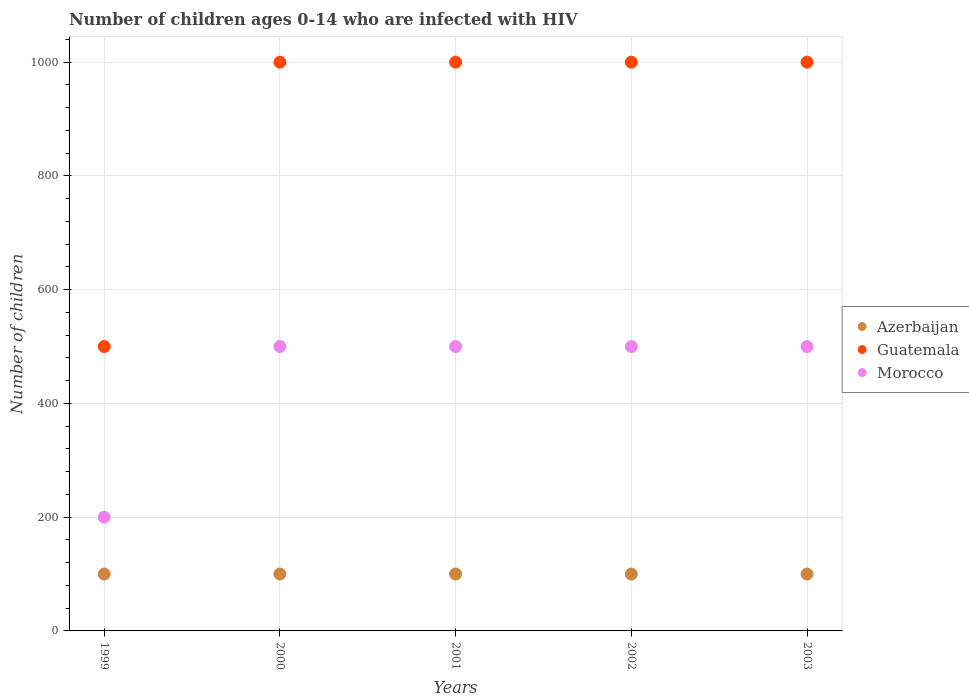What is the number of HIV infected children in Morocco in 1999?
Keep it short and to the point. 200. Across all years, what is the maximum number of HIV infected children in Azerbaijan?
Give a very brief answer. 100. Across all years, what is the minimum number of HIV infected children in Morocco?
Your answer should be very brief. 200. What is the total number of HIV infected children in Guatemala in the graph?
Your answer should be very brief. 4500. What is the difference between the number of HIV infected children in Morocco in 1999 and that in 2003?
Ensure brevity in your answer.  -300. What is the difference between the number of HIV infected children in Azerbaijan in 2003 and the number of HIV infected children in Guatemala in 1999?
Give a very brief answer. -400. In the year 2000, what is the difference between the number of HIV infected children in Azerbaijan and number of HIV infected children in Guatemala?
Your answer should be compact. -900. What is the ratio of the number of HIV infected children in Azerbaijan in 1999 to that in 2001?
Offer a terse response. 1. Is the number of HIV infected children in Morocco in 2001 less than that in 2003?
Give a very brief answer. No. Is the sum of the number of HIV infected children in Guatemala in 2000 and 2001 greater than the maximum number of HIV infected children in Azerbaijan across all years?
Offer a terse response. Yes. Is it the case that in every year, the sum of the number of HIV infected children in Guatemala and number of HIV infected children in Azerbaijan  is greater than the number of HIV infected children in Morocco?
Ensure brevity in your answer.  Yes. Is the number of HIV infected children in Morocco strictly greater than the number of HIV infected children in Guatemala over the years?
Give a very brief answer. No. Is the number of HIV infected children in Azerbaijan strictly less than the number of HIV infected children in Guatemala over the years?
Keep it short and to the point. Yes. How many years are there in the graph?
Offer a very short reply. 5. Does the graph contain any zero values?
Your answer should be compact. No. Does the graph contain grids?
Your response must be concise. Yes. How many legend labels are there?
Provide a short and direct response. 3. What is the title of the graph?
Ensure brevity in your answer.  Number of children ages 0-14 who are infected with HIV. Does "Dominican Republic" appear as one of the legend labels in the graph?
Offer a very short reply. No. What is the label or title of the Y-axis?
Offer a terse response. Number of children. What is the Number of children of Morocco in 1999?
Offer a very short reply. 200. What is the Number of children of Morocco in 2001?
Provide a succinct answer. 500. What is the Number of children in Guatemala in 2002?
Ensure brevity in your answer.  1000. What is the Number of children in Guatemala in 2003?
Your response must be concise. 1000. What is the Number of children in Morocco in 2003?
Offer a terse response. 500. Across all years, what is the minimum Number of children in Azerbaijan?
Provide a short and direct response. 100. Across all years, what is the minimum Number of children in Guatemala?
Give a very brief answer. 500. Across all years, what is the minimum Number of children of Morocco?
Make the answer very short. 200. What is the total Number of children in Guatemala in the graph?
Your response must be concise. 4500. What is the total Number of children in Morocco in the graph?
Provide a succinct answer. 2200. What is the difference between the Number of children of Guatemala in 1999 and that in 2000?
Give a very brief answer. -500. What is the difference between the Number of children of Morocco in 1999 and that in 2000?
Make the answer very short. -300. What is the difference between the Number of children of Guatemala in 1999 and that in 2001?
Offer a very short reply. -500. What is the difference between the Number of children in Morocco in 1999 and that in 2001?
Your answer should be very brief. -300. What is the difference between the Number of children in Guatemala in 1999 and that in 2002?
Provide a succinct answer. -500. What is the difference between the Number of children of Morocco in 1999 and that in 2002?
Make the answer very short. -300. What is the difference between the Number of children of Guatemala in 1999 and that in 2003?
Make the answer very short. -500. What is the difference between the Number of children in Morocco in 1999 and that in 2003?
Ensure brevity in your answer.  -300. What is the difference between the Number of children of Guatemala in 2000 and that in 2001?
Your answer should be very brief. 0. What is the difference between the Number of children in Guatemala in 2000 and that in 2003?
Give a very brief answer. 0. What is the difference between the Number of children of Morocco in 2000 and that in 2003?
Give a very brief answer. 0. What is the difference between the Number of children in Azerbaijan in 1999 and the Number of children in Guatemala in 2000?
Provide a succinct answer. -900. What is the difference between the Number of children of Azerbaijan in 1999 and the Number of children of Morocco in 2000?
Provide a succinct answer. -400. What is the difference between the Number of children in Guatemala in 1999 and the Number of children in Morocco in 2000?
Give a very brief answer. 0. What is the difference between the Number of children of Azerbaijan in 1999 and the Number of children of Guatemala in 2001?
Ensure brevity in your answer.  -900. What is the difference between the Number of children in Azerbaijan in 1999 and the Number of children in Morocco in 2001?
Keep it short and to the point. -400. What is the difference between the Number of children of Guatemala in 1999 and the Number of children of Morocco in 2001?
Keep it short and to the point. 0. What is the difference between the Number of children in Azerbaijan in 1999 and the Number of children in Guatemala in 2002?
Give a very brief answer. -900. What is the difference between the Number of children in Azerbaijan in 1999 and the Number of children in Morocco in 2002?
Give a very brief answer. -400. What is the difference between the Number of children of Guatemala in 1999 and the Number of children of Morocco in 2002?
Provide a short and direct response. 0. What is the difference between the Number of children of Azerbaijan in 1999 and the Number of children of Guatemala in 2003?
Your answer should be very brief. -900. What is the difference between the Number of children in Azerbaijan in 1999 and the Number of children in Morocco in 2003?
Provide a succinct answer. -400. What is the difference between the Number of children of Guatemala in 1999 and the Number of children of Morocco in 2003?
Ensure brevity in your answer.  0. What is the difference between the Number of children in Azerbaijan in 2000 and the Number of children in Guatemala in 2001?
Your response must be concise. -900. What is the difference between the Number of children in Azerbaijan in 2000 and the Number of children in Morocco in 2001?
Keep it short and to the point. -400. What is the difference between the Number of children in Guatemala in 2000 and the Number of children in Morocco in 2001?
Ensure brevity in your answer.  500. What is the difference between the Number of children of Azerbaijan in 2000 and the Number of children of Guatemala in 2002?
Offer a terse response. -900. What is the difference between the Number of children in Azerbaijan in 2000 and the Number of children in Morocco in 2002?
Provide a succinct answer. -400. What is the difference between the Number of children of Guatemala in 2000 and the Number of children of Morocco in 2002?
Your response must be concise. 500. What is the difference between the Number of children in Azerbaijan in 2000 and the Number of children in Guatemala in 2003?
Offer a very short reply. -900. What is the difference between the Number of children in Azerbaijan in 2000 and the Number of children in Morocco in 2003?
Your answer should be compact. -400. What is the difference between the Number of children in Guatemala in 2000 and the Number of children in Morocco in 2003?
Offer a very short reply. 500. What is the difference between the Number of children in Azerbaijan in 2001 and the Number of children in Guatemala in 2002?
Offer a terse response. -900. What is the difference between the Number of children of Azerbaijan in 2001 and the Number of children of Morocco in 2002?
Your answer should be very brief. -400. What is the difference between the Number of children in Guatemala in 2001 and the Number of children in Morocco in 2002?
Keep it short and to the point. 500. What is the difference between the Number of children of Azerbaijan in 2001 and the Number of children of Guatemala in 2003?
Provide a succinct answer. -900. What is the difference between the Number of children in Azerbaijan in 2001 and the Number of children in Morocco in 2003?
Offer a very short reply. -400. What is the difference between the Number of children of Azerbaijan in 2002 and the Number of children of Guatemala in 2003?
Provide a succinct answer. -900. What is the difference between the Number of children in Azerbaijan in 2002 and the Number of children in Morocco in 2003?
Your response must be concise. -400. What is the difference between the Number of children of Guatemala in 2002 and the Number of children of Morocco in 2003?
Your answer should be compact. 500. What is the average Number of children in Azerbaijan per year?
Your answer should be compact. 100. What is the average Number of children in Guatemala per year?
Your response must be concise. 900. What is the average Number of children in Morocco per year?
Your answer should be compact. 440. In the year 1999, what is the difference between the Number of children in Azerbaijan and Number of children in Guatemala?
Your answer should be compact. -400. In the year 1999, what is the difference between the Number of children in Azerbaijan and Number of children in Morocco?
Offer a very short reply. -100. In the year 1999, what is the difference between the Number of children of Guatemala and Number of children of Morocco?
Ensure brevity in your answer.  300. In the year 2000, what is the difference between the Number of children in Azerbaijan and Number of children in Guatemala?
Give a very brief answer. -900. In the year 2000, what is the difference between the Number of children in Azerbaijan and Number of children in Morocco?
Your answer should be compact. -400. In the year 2001, what is the difference between the Number of children of Azerbaijan and Number of children of Guatemala?
Provide a succinct answer. -900. In the year 2001, what is the difference between the Number of children in Azerbaijan and Number of children in Morocco?
Your response must be concise. -400. In the year 2001, what is the difference between the Number of children of Guatemala and Number of children of Morocco?
Offer a terse response. 500. In the year 2002, what is the difference between the Number of children of Azerbaijan and Number of children of Guatemala?
Offer a very short reply. -900. In the year 2002, what is the difference between the Number of children in Azerbaijan and Number of children in Morocco?
Offer a terse response. -400. In the year 2003, what is the difference between the Number of children of Azerbaijan and Number of children of Guatemala?
Provide a succinct answer. -900. In the year 2003, what is the difference between the Number of children of Azerbaijan and Number of children of Morocco?
Provide a succinct answer. -400. What is the ratio of the Number of children of Azerbaijan in 1999 to that in 2000?
Provide a succinct answer. 1. What is the ratio of the Number of children in Morocco in 1999 to that in 2000?
Your response must be concise. 0.4. What is the ratio of the Number of children in Azerbaijan in 1999 to that in 2001?
Make the answer very short. 1. What is the ratio of the Number of children of Morocco in 1999 to that in 2001?
Your response must be concise. 0.4. What is the ratio of the Number of children in Morocco in 1999 to that in 2002?
Offer a very short reply. 0.4. What is the ratio of the Number of children of Azerbaijan in 2000 to that in 2001?
Ensure brevity in your answer.  1. What is the ratio of the Number of children of Azerbaijan in 2000 to that in 2002?
Make the answer very short. 1. What is the ratio of the Number of children in Morocco in 2000 to that in 2003?
Your answer should be compact. 1. What is the ratio of the Number of children in Morocco in 2001 to that in 2002?
Offer a terse response. 1. What is the ratio of the Number of children in Guatemala in 2001 to that in 2003?
Your response must be concise. 1. What is the ratio of the Number of children of Azerbaijan in 2002 to that in 2003?
Offer a very short reply. 1. What is the ratio of the Number of children of Morocco in 2002 to that in 2003?
Ensure brevity in your answer.  1. What is the difference between the highest and the second highest Number of children in Azerbaijan?
Provide a short and direct response. 0. What is the difference between the highest and the second highest Number of children of Guatemala?
Your answer should be compact. 0. What is the difference between the highest and the lowest Number of children in Azerbaijan?
Your answer should be compact. 0. What is the difference between the highest and the lowest Number of children in Guatemala?
Provide a succinct answer. 500. What is the difference between the highest and the lowest Number of children in Morocco?
Your answer should be compact. 300. 